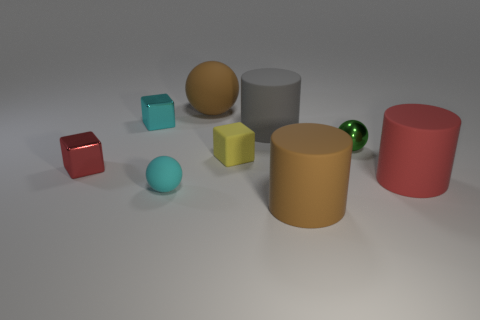There is a large thing that is the same color as the big matte ball; what shape is it?
Provide a succinct answer. Cylinder. How many red metallic blocks are the same size as the green metal object?
Make the answer very short. 1. There is a large sphere; how many tiny cyan cubes are to the right of it?
Offer a terse response. 0. What is the cylinder that is in front of the rubber thing that is on the left side of the big sphere made of?
Your answer should be very brief. Rubber. Is there a rubber object that has the same color as the small matte sphere?
Keep it short and to the point. No. There is a gray cylinder that is the same material as the large brown cylinder; what size is it?
Provide a succinct answer. Large. Is there anything else of the same color as the big matte ball?
Provide a short and direct response. Yes. What color is the ball that is right of the gray object?
Keep it short and to the point. Green. Is there a big red cylinder that is to the left of the cyan thing behind the rubber sphere that is in front of the large red cylinder?
Keep it short and to the point. No. Is the number of tiny cyan metallic objects on the right side of the tiny cyan matte object greater than the number of brown things?
Keep it short and to the point. No. 